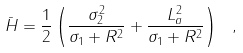<formula> <loc_0><loc_0><loc_500><loc_500>\bar { H } = \frac { 1 } { 2 } \left ( \frac { \sigma ^ { 2 } _ { 2 } } { \sigma _ { 1 } + R ^ { 2 } } + \frac { L ^ { 2 } _ { a } } { \sigma _ { 1 } + R ^ { 2 } } \right ) \ ,</formula> 